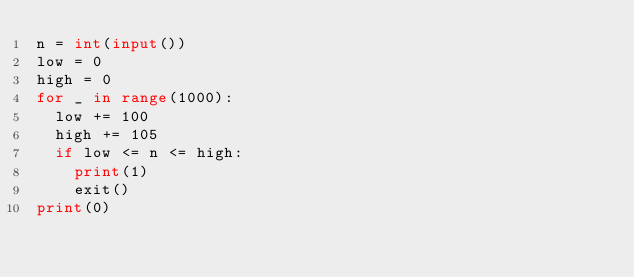Convert code to text. <code><loc_0><loc_0><loc_500><loc_500><_Python_>n = int(input())
low = 0
high = 0
for _ in range(1000):
  low += 100
  high += 105
  if low <= n <= high:
    print(1)
    exit()
print(0)</code> 